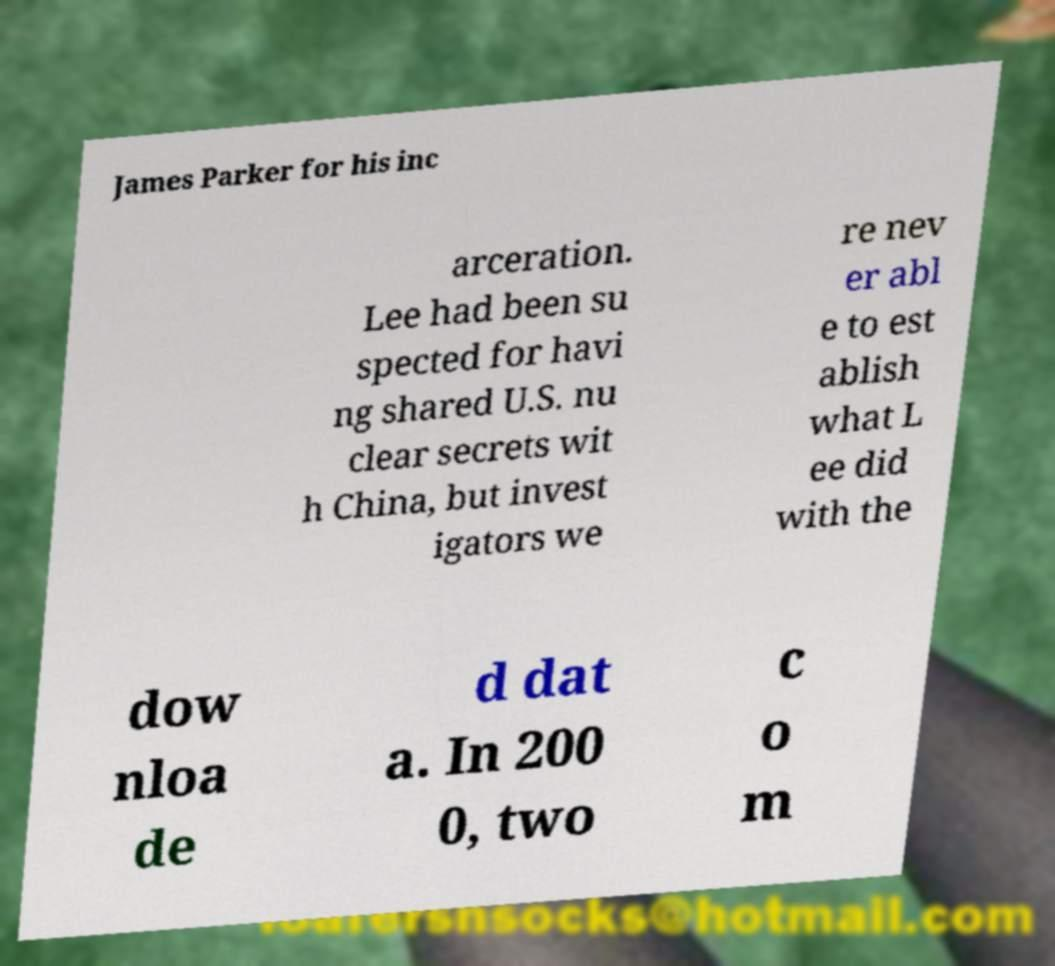For documentation purposes, I need the text within this image transcribed. Could you provide that? James Parker for his inc arceration. Lee had been su spected for havi ng shared U.S. nu clear secrets wit h China, but invest igators we re nev er abl e to est ablish what L ee did with the dow nloa de d dat a. In 200 0, two c o m 